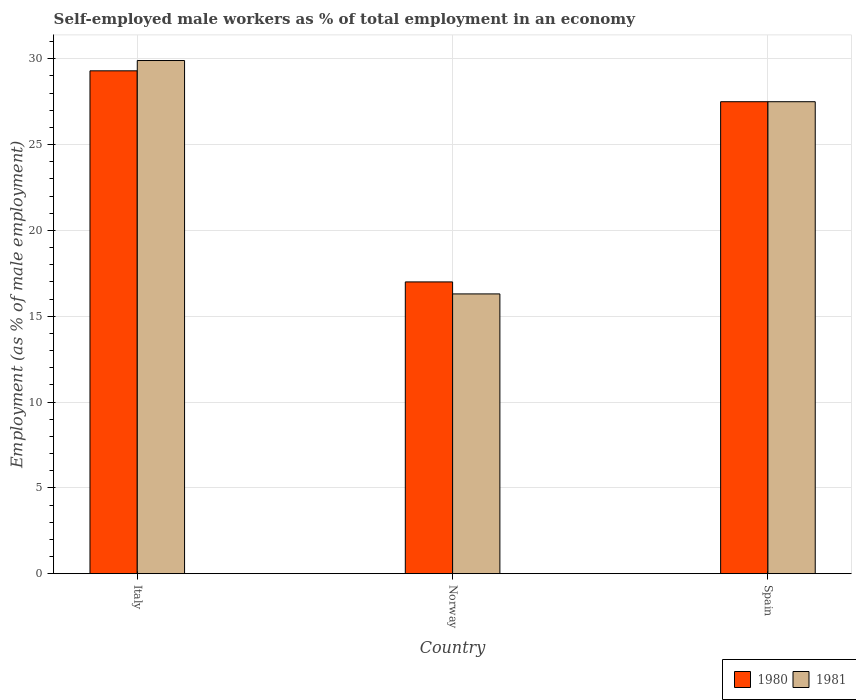How many different coloured bars are there?
Your answer should be compact. 2. How many groups of bars are there?
Ensure brevity in your answer.  3. Are the number of bars per tick equal to the number of legend labels?
Provide a short and direct response. Yes. Are the number of bars on each tick of the X-axis equal?
Offer a terse response. Yes. How many bars are there on the 2nd tick from the right?
Your answer should be very brief. 2. In how many cases, is the number of bars for a given country not equal to the number of legend labels?
Your answer should be very brief. 0. What is the percentage of self-employed male workers in 1980 in Norway?
Your answer should be compact. 17. Across all countries, what is the maximum percentage of self-employed male workers in 1980?
Ensure brevity in your answer.  29.3. Across all countries, what is the minimum percentage of self-employed male workers in 1981?
Provide a short and direct response. 16.3. What is the total percentage of self-employed male workers in 1981 in the graph?
Provide a succinct answer. 73.7. What is the difference between the percentage of self-employed male workers in 1981 in Italy and that in Spain?
Your response must be concise. 2.4. What is the difference between the percentage of self-employed male workers in 1980 in Norway and the percentage of self-employed male workers in 1981 in Spain?
Provide a succinct answer. -10.5. What is the average percentage of self-employed male workers in 1981 per country?
Your answer should be compact. 24.57. What is the difference between the percentage of self-employed male workers of/in 1981 and percentage of self-employed male workers of/in 1980 in Italy?
Your response must be concise. 0.6. In how many countries, is the percentage of self-employed male workers in 1981 greater than 16 %?
Provide a short and direct response. 3. What is the ratio of the percentage of self-employed male workers in 1981 in Italy to that in Spain?
Offer a terse response. 1.09. What is the difference between the highest and the second highest percentage of self-employed male workers in 1980?
Your response must be concise. -10.5. What is the difference between the highest and the lowest percentage of self-employed male workers in 1980?
Provide a succinct answer. 12.3. How many bars are there?
Your answer should be very brief. 6. Are all the bars in the graph horizontal?
Keep it short and to the point. No. What is the difference between two consecutive major ticks on the Y-axis?
Give a very brief answer. 5. Does the graph contain any zero values?
Provide a short and direct response. No. Does the graph contain grids?
Your answer should be very brief. Yes. How are the legend labels stacked?
Make the answer very short. Horizontal. What is the title of the graph?
Provide a short and direct response. Self-employed male workers as % of total employment in an economy. Does "1981" appear as one of the legend labels in the graph?
Keep it short and to the point. Yes. What is the label or title of the Y-axis?
Make the answer very short. Employment (as % of male employment). What is the Employment (as % of male employment) of 1980 in Italy?
Your answer should be very brief. 29.3. What is the Employment (as % of male employment) of 1981 in Italy?
Your response must be concise. 29.9. What is the Employment (as % of male employment) in 1980 in Norway?
Offer a very short reply. 17. What is the Employment (as % of male employment) of 1981 in Norway?
Offer a terse response. 16.3. Across all countries, what is the maximum Employment (as % of male employment) of 1980?
Provide a succinct answer. 29.3. Across all countries, what is the maximum Employment (as % of male employment) in 1981?
Make the answer very short. 29.9. Across all countries, what is the minimum Employment (as % of male employment) in 1980?
Offer a very short reply. 17. Across all countries, what is the minimum Employment (as % of male employment) in 1981?
Provide a succinct answer. 16.3. What is the total Employment (as % of male employment) in 1980 in the graph?
Provide a succinct answer. 73.8. What is the total Employment (as % of male employment) of 1981 in the graph?
Provide a succinct answer. 73.7. What is the difference between the Employment (as % of male employment) in 1981 in Italy and that in Norway?
Your answer should be compact. 13.6. What is the difference between the Employment (as % of male employment) in 1981 in Italy and that in Spain?
Give a very brief answer. 2.4. What is the difference between the Employment (as % of male employment) of 1980 in Norway and that in Spain?
Give a very brief answer. -10.5. What is the difference between the Employment (as % of male employment) of 1981 in Norway and that in Spain?
Your response must be concise. -11.2. What is the difference between the Employment (as % of male employment) in 1980 in Italy and the Employment (as % of male employment) in 1981 in Norway?
Provide a succinct answer. 13. What is the average Employment (as % of male employment) of 1980 per country?
Ensure brevity in your answer.  24.6. What is the average Employment (as % of male employment) in 1981 per country?
Your response must be concise. 24.57. What is the ratio of the Employment (as % of male employment) in 1980 in Italy to that in Norway?
Make the answer very short. 1.72. What is the ratio of the Employment (as % of male employment) of 1981 in Italy to that in Norway?
Offer a very short reply. 1.83. What is the ratio of the Employment (as % of male employment) of 1980 in Italy to that in Spain?
Your answer should be very brief. 1.07. What is the ratio of the Employment (as % of male employment) in 1981 in Italy to that in Spain?
Your answer should be compact. 1.09. What is the ratio of the Employment (as % of male employment) in 1980 in Norway to that in Spain?
Give a very brief answer. 0.62. What is the ratio of the Employment (as % of male employment) of 1981 in Norway to that in Spain?
Keep it short and to the point. 0.59. What is the difference between the highest and the second highest Employment (as % of male employment) of 1980?
Make the answer very short. 1.8. What is the difference between the highest and the second highest Employment (as % of male employment) in 1981?
Offer a terse response. 2.4. 